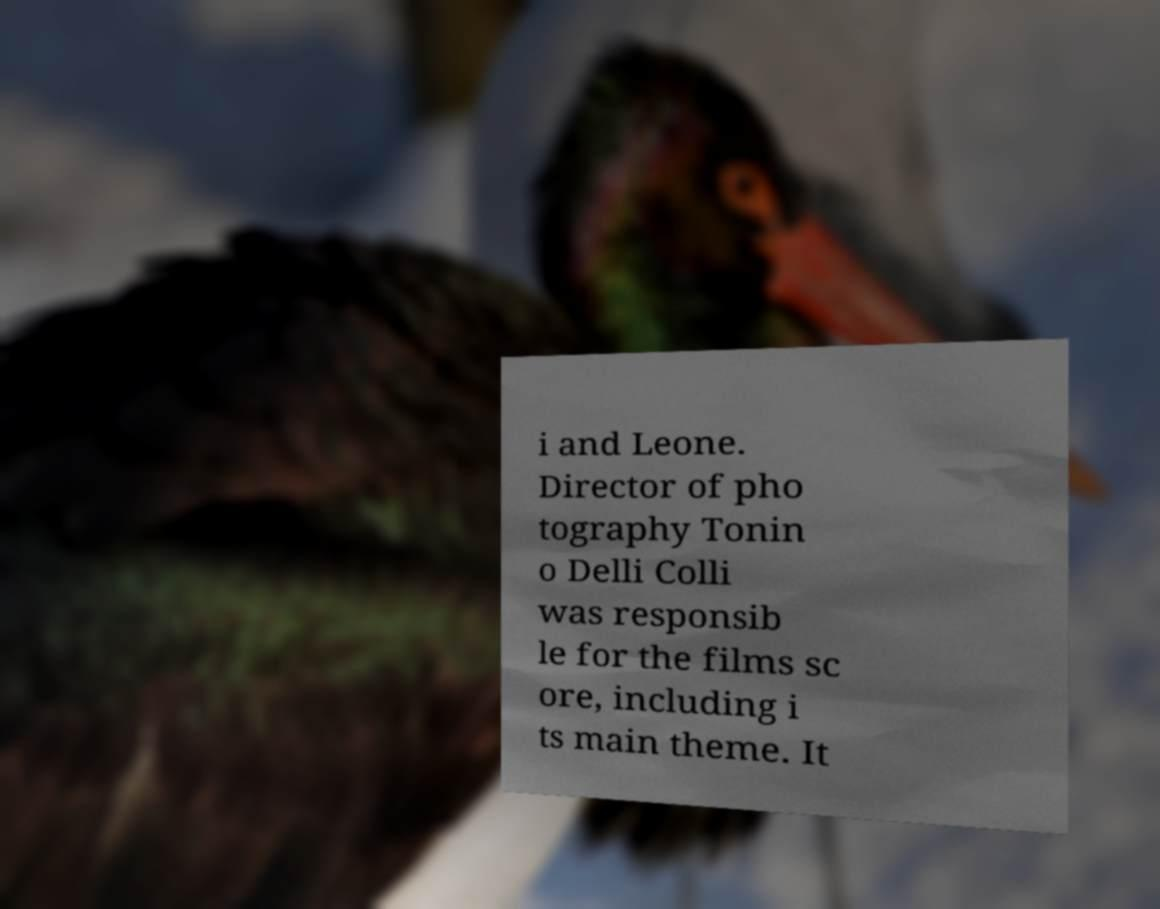There's text embedded in this image that I need extracted. Can you transcribe it verbatim? i and Leone. Director of pho tography Tonin o Delli Colli was responsib le for the films sc ore, including i ts main theme. It 